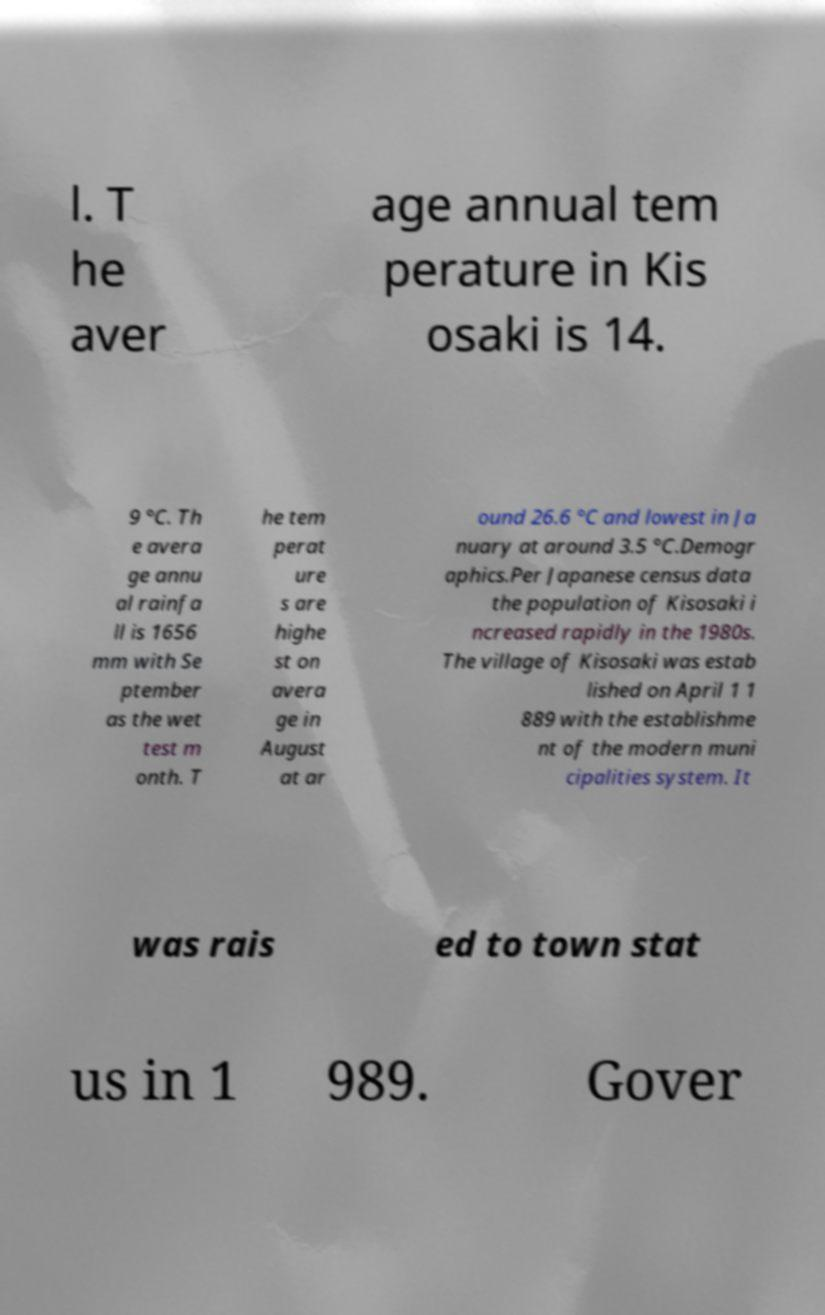Could you extract and type out the text from this image? l. T he aver age annual tem perature in Kis osaki is 14. 9 °C. Th e avera ge annu al rainfa ll is 1656 mm with Se ptember as the wet test m onth. T he tem perat ure s are highe st on avera ge in August at ar ound 26.6 °C and lowest in Ja nuary at around 3.5 °C.Demogr aphics.Per Japanese census data the population of Kisosaki i ncreased rapidly in the 1980s. The village of Kisosaki was estab lished on April 1 1 889 with the establishme nt of the modern muni cipalities system. It was rais ed to town stat us in 1 989. Gover 